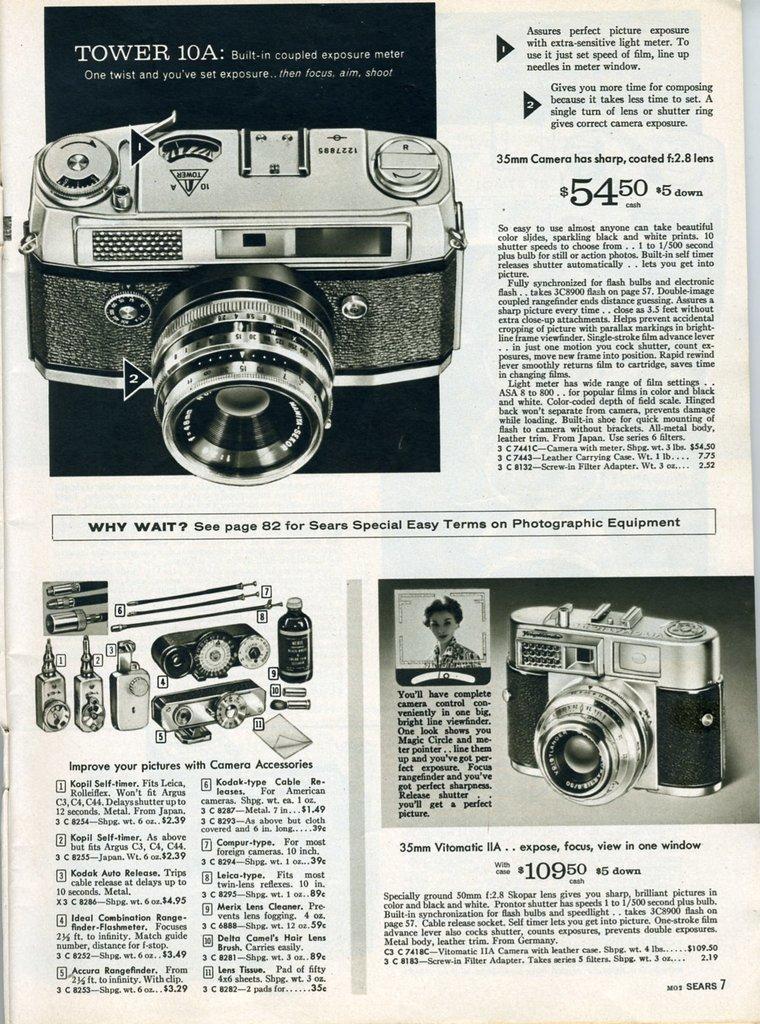Can you describe this image briefly? This picture consists of a page, which contains information about a camera in the image. 